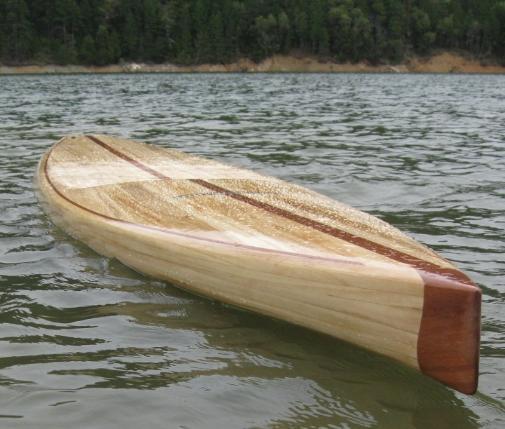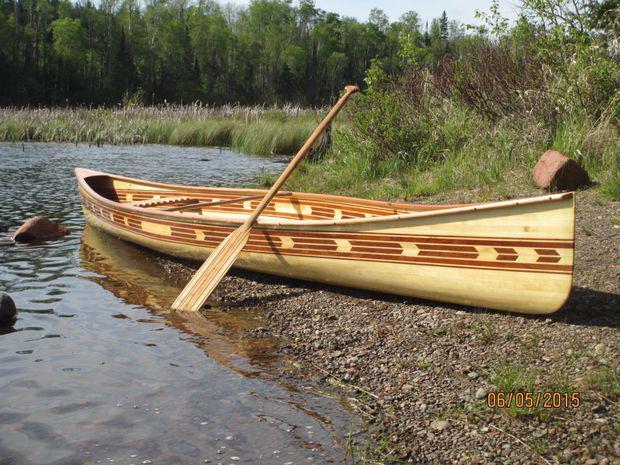The first image is the image on the left, the second image is the image on the right. Considering the images on both sides, is "there is an oar laying across the boat" valid? Answer yes or no. Yes. 